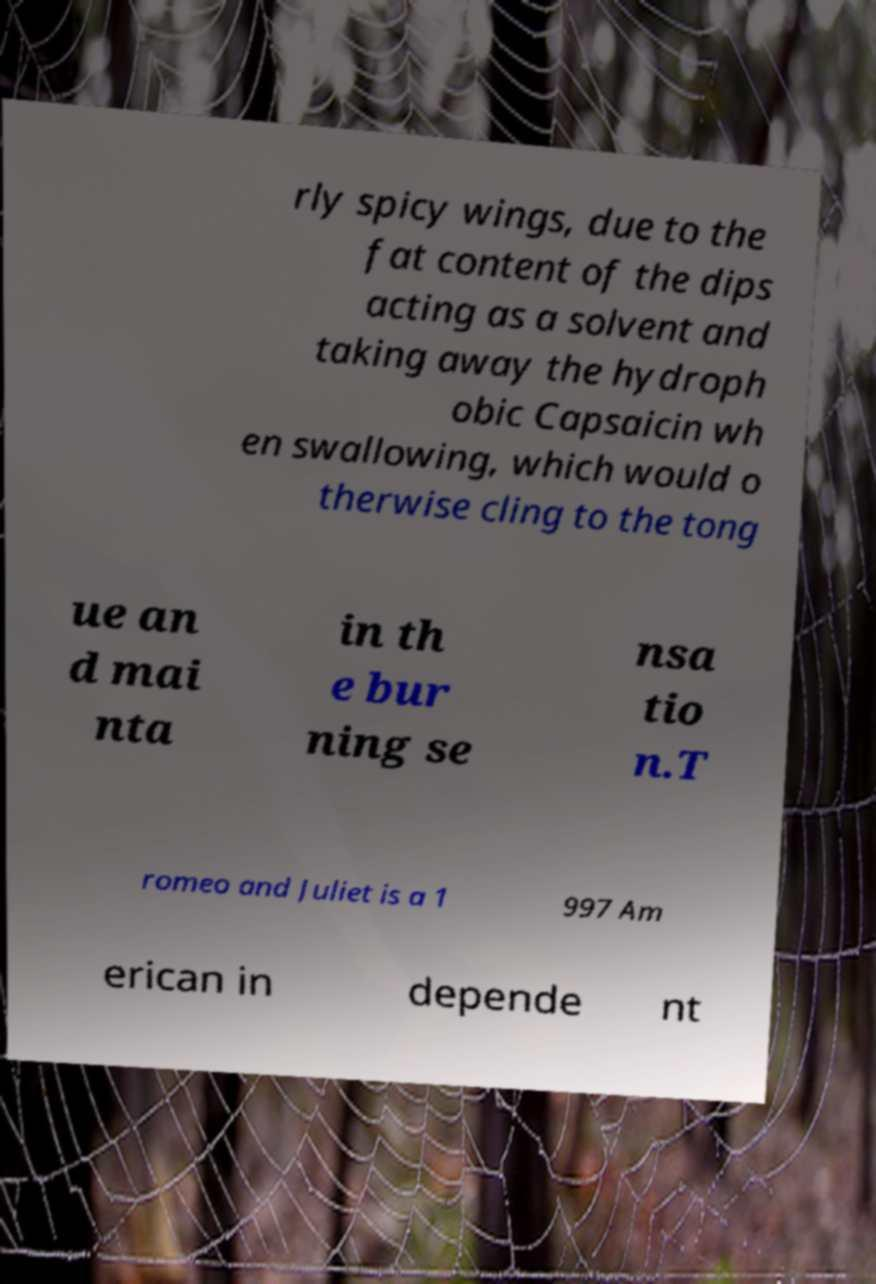There's text embedded in this image that I need extracted. Can you transcribe it verbatim? rly spicy wings, due to the fat content of the dips acting as a solvent and taking away the hydroph obic Capsaicin wh en swallowing, which would o therwise cling to the tong ue an d mai nta in th e bur ning se nsa tio n.T romeo and Juliet is a 1 997 Am erican in depende nt 